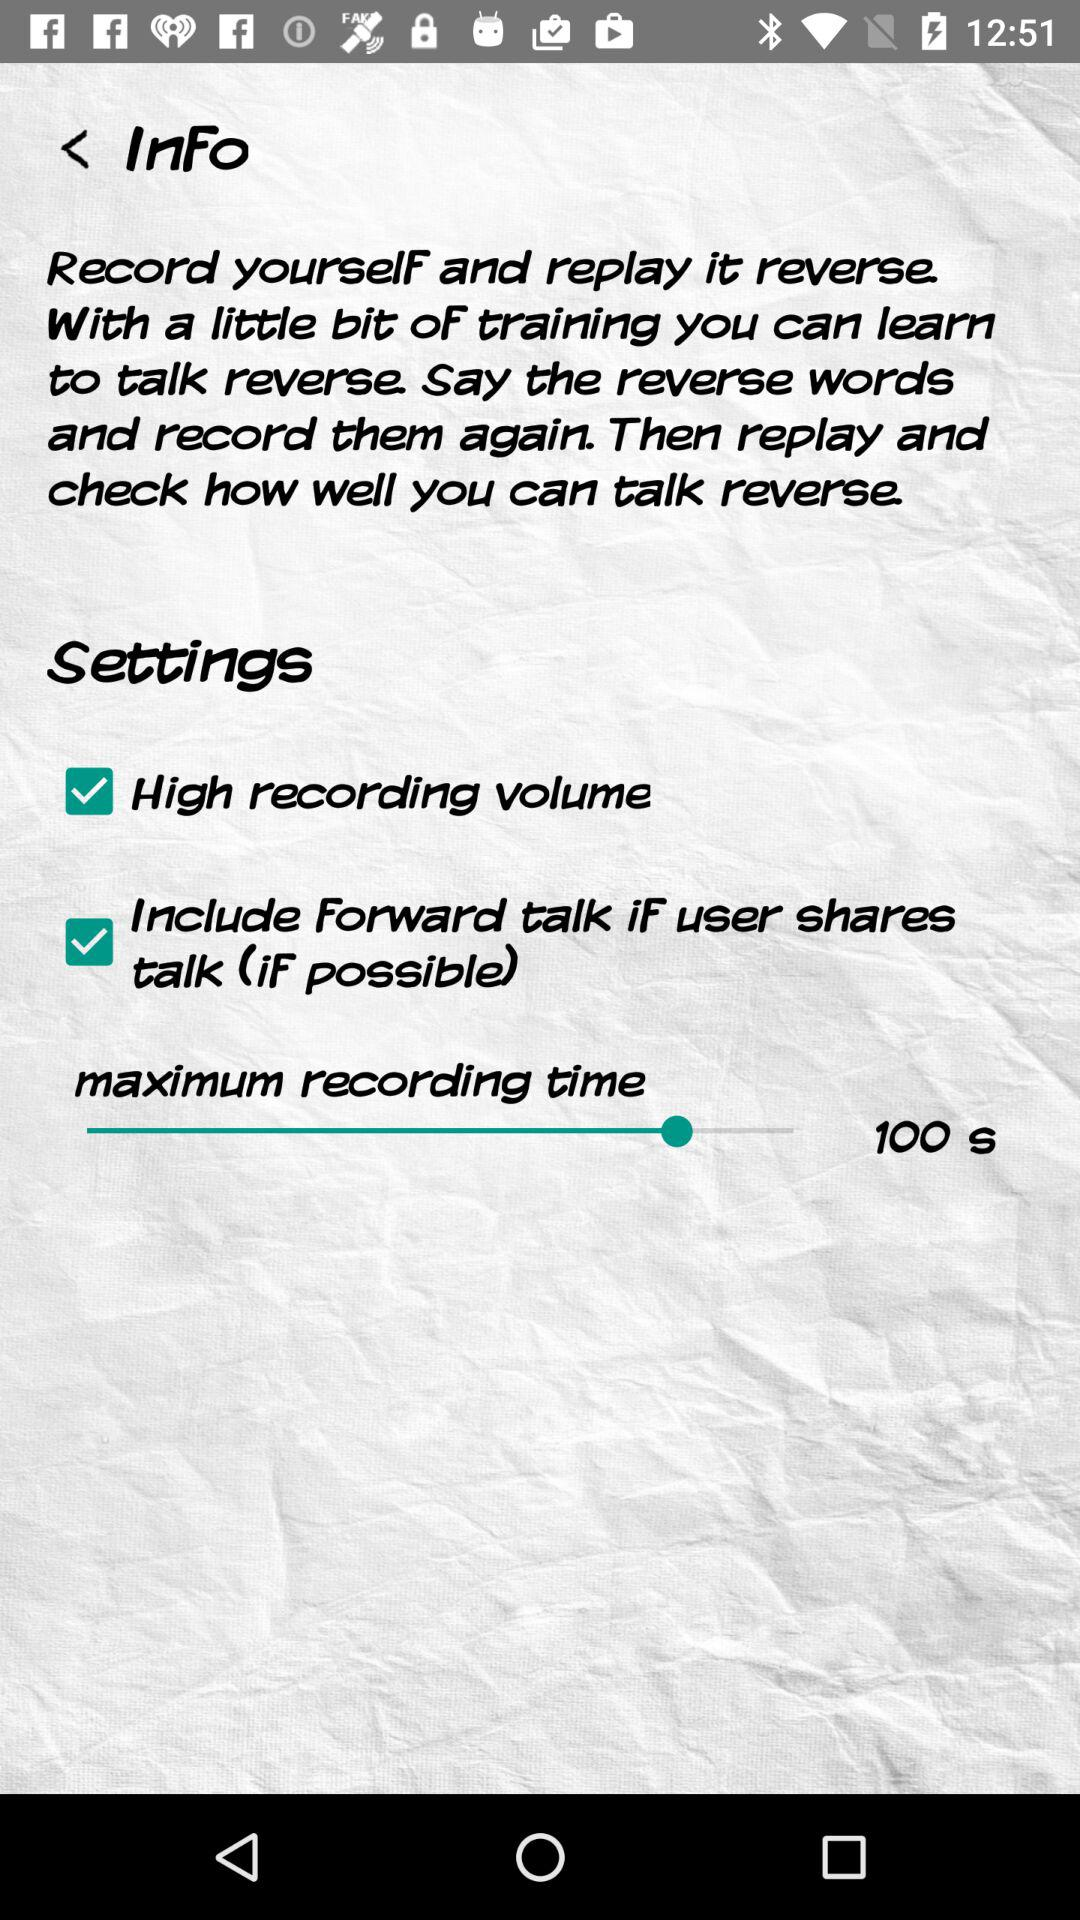What's the maximum recording time? The maximum recording time is 100 seconds. 